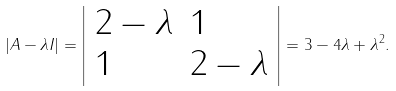Convert formula to latex. <formula><loc_0><loc_0><loc_500><loc_500>| A - \lambda I | = { \left | \begin{array} { l l } { 2 - \lambda } & { 1 } \\ { 1 } & { 2 - \lambda } \end{array} \right | } = 3 - 4 \lambda + \lambda ^ { 2 } .</formula> 